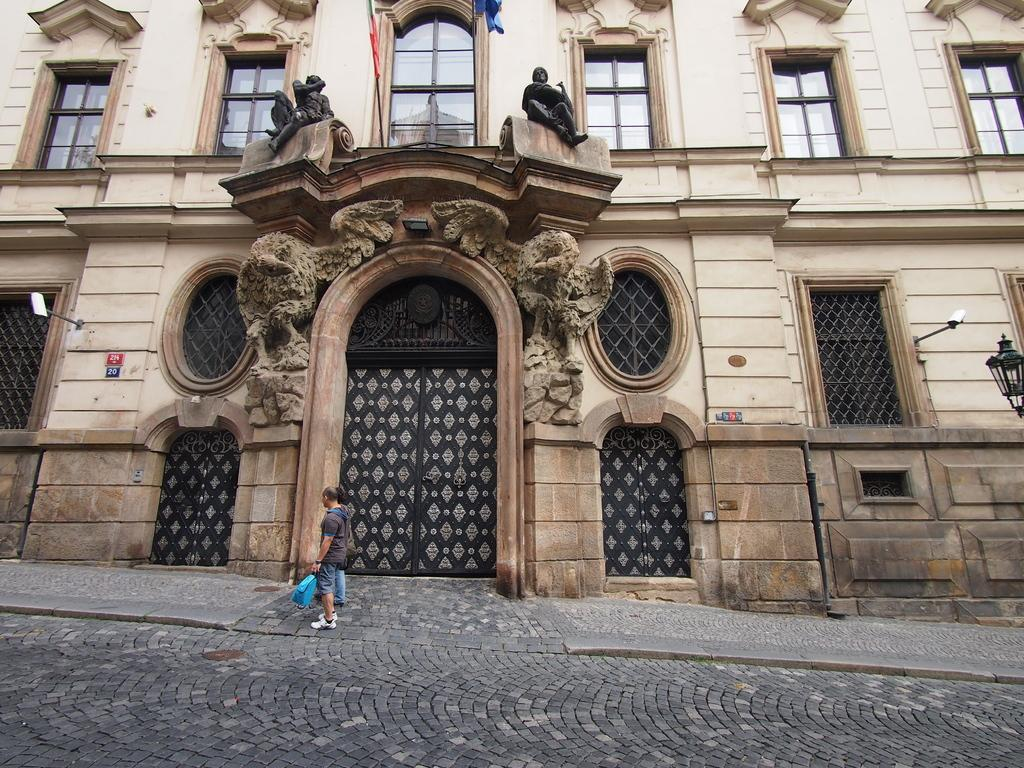What type of structure is present in the image? There is a building in the image. What features can be observed on the building? The building has windows and doors. Can you describe the lighting conditions in the image? There is light visible in the image. What additional elements are present in the image? There are flags and sculptures in the image. Are there any people in the image? Yes, there are people in the image. What are the people doing in the image? The people are on a path. What type of plantation can be seen in the image? There is no plantation present in the image. Can you tell me how many knives are being used by the people in the image? There are no knives visible in the image; the people are on a path. 